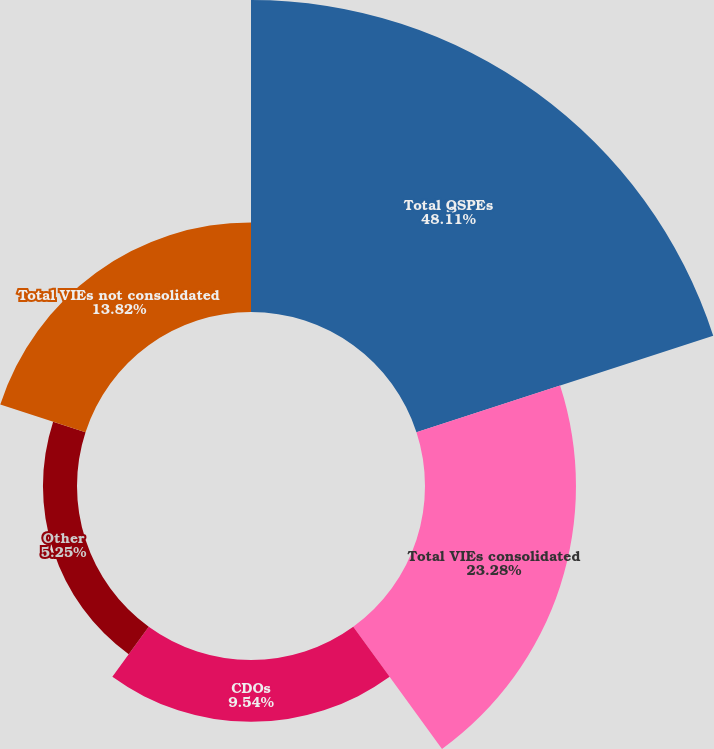<chart> <loc_0><loc_0><loc_500><loc_500><pie_chart><fcel>Total QSPEs<fcel>Total VIEs consolidated<fcel>CDOs<fcel>Other<fcel>Total VIEs not consolidated<nl><fcel>48.11%<fcel>23.28%<fcel>9.54%<fcel>5.25%<fcel>13.82%<nl></chart> 